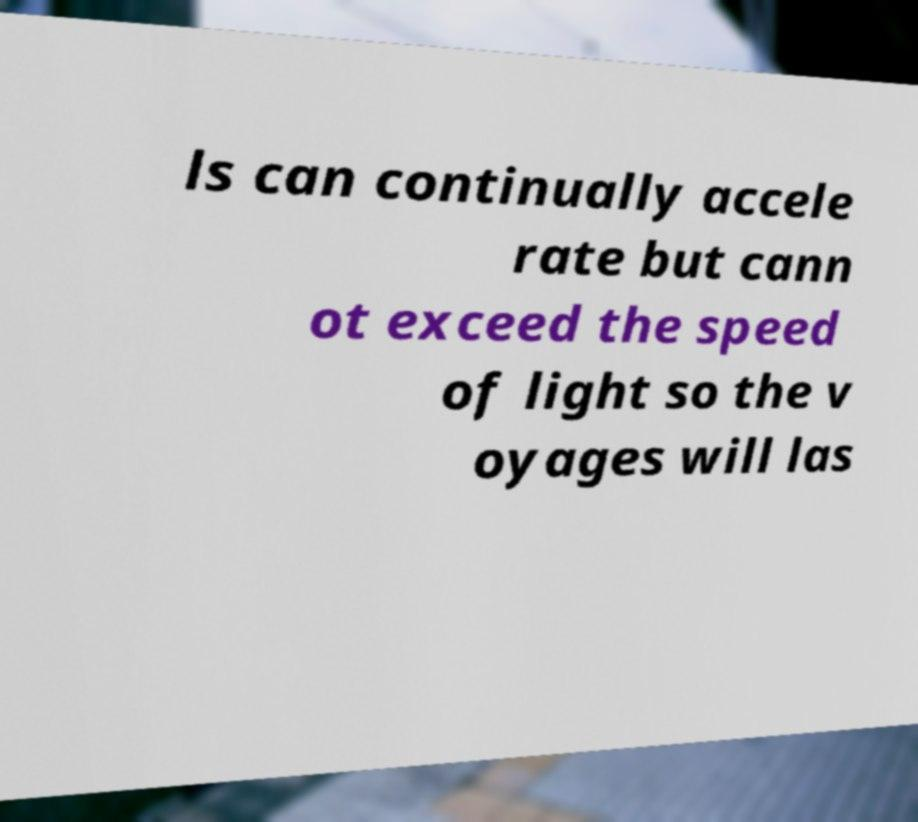Can you accurately transcribe the text from the provided image for me? ls can continually accele rate but cann ot exceed the speed of light so the v oyages will las 